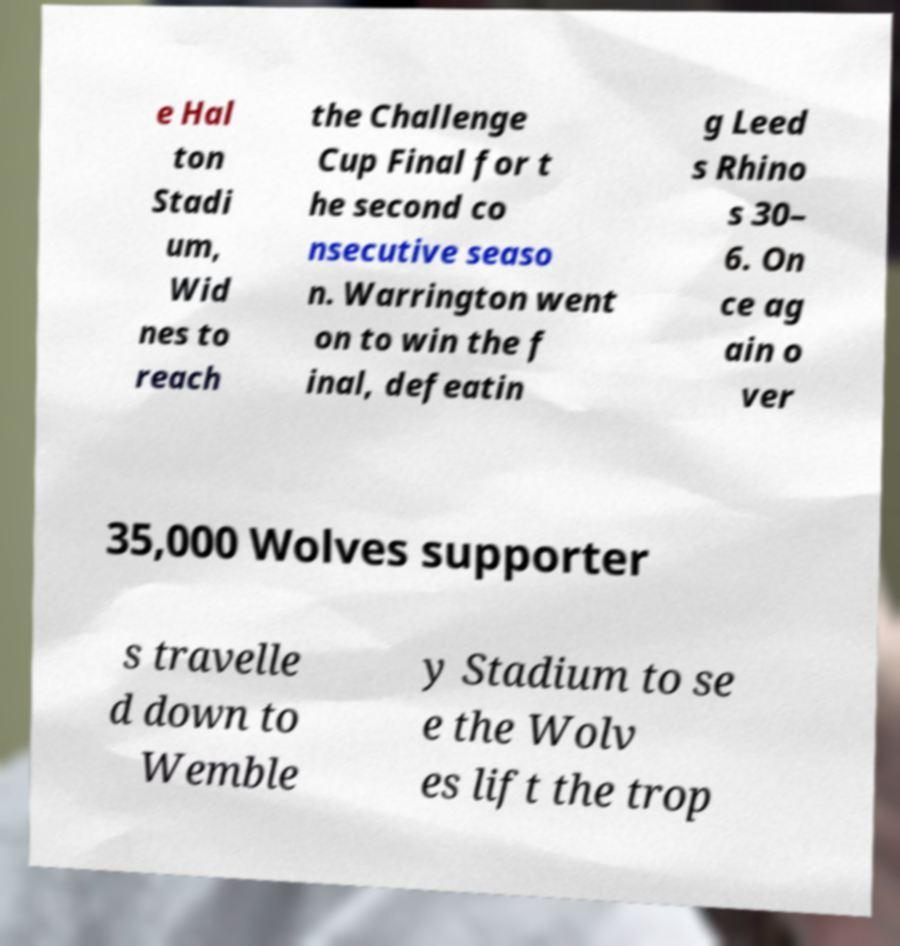Could you assist in decoding the text presented in this image and type it out clearly? e Hal ton Stadi um, Wid nes to reach the Challenge Cup Final for t he second co nsecutive seaso n. Warrington went on to win the f inal, defeatin g Leed s Rhino s 30– 6. On ce ag ain o ver 35,000 Wolves supporter s travelle d down to Wemble y Stadium to se e the Wolv es lift the trop 